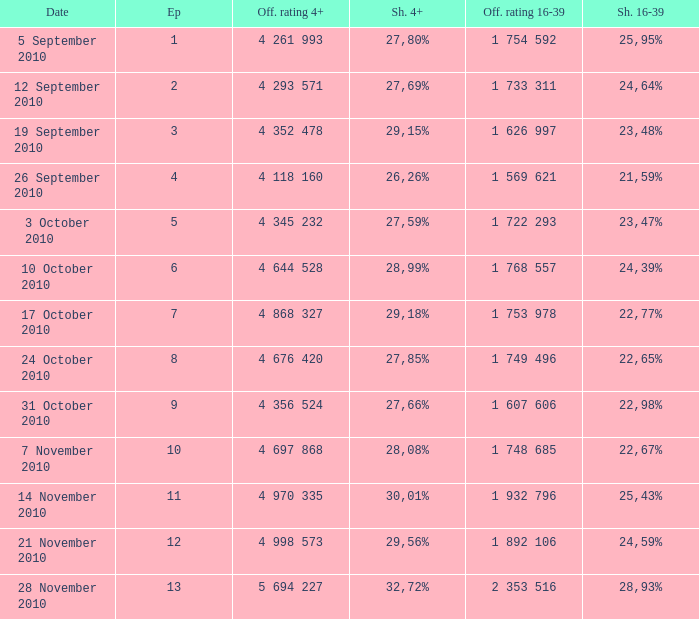What is the 16-39 share of the episode with a 4+ share of 30,01%? 25,43%. 